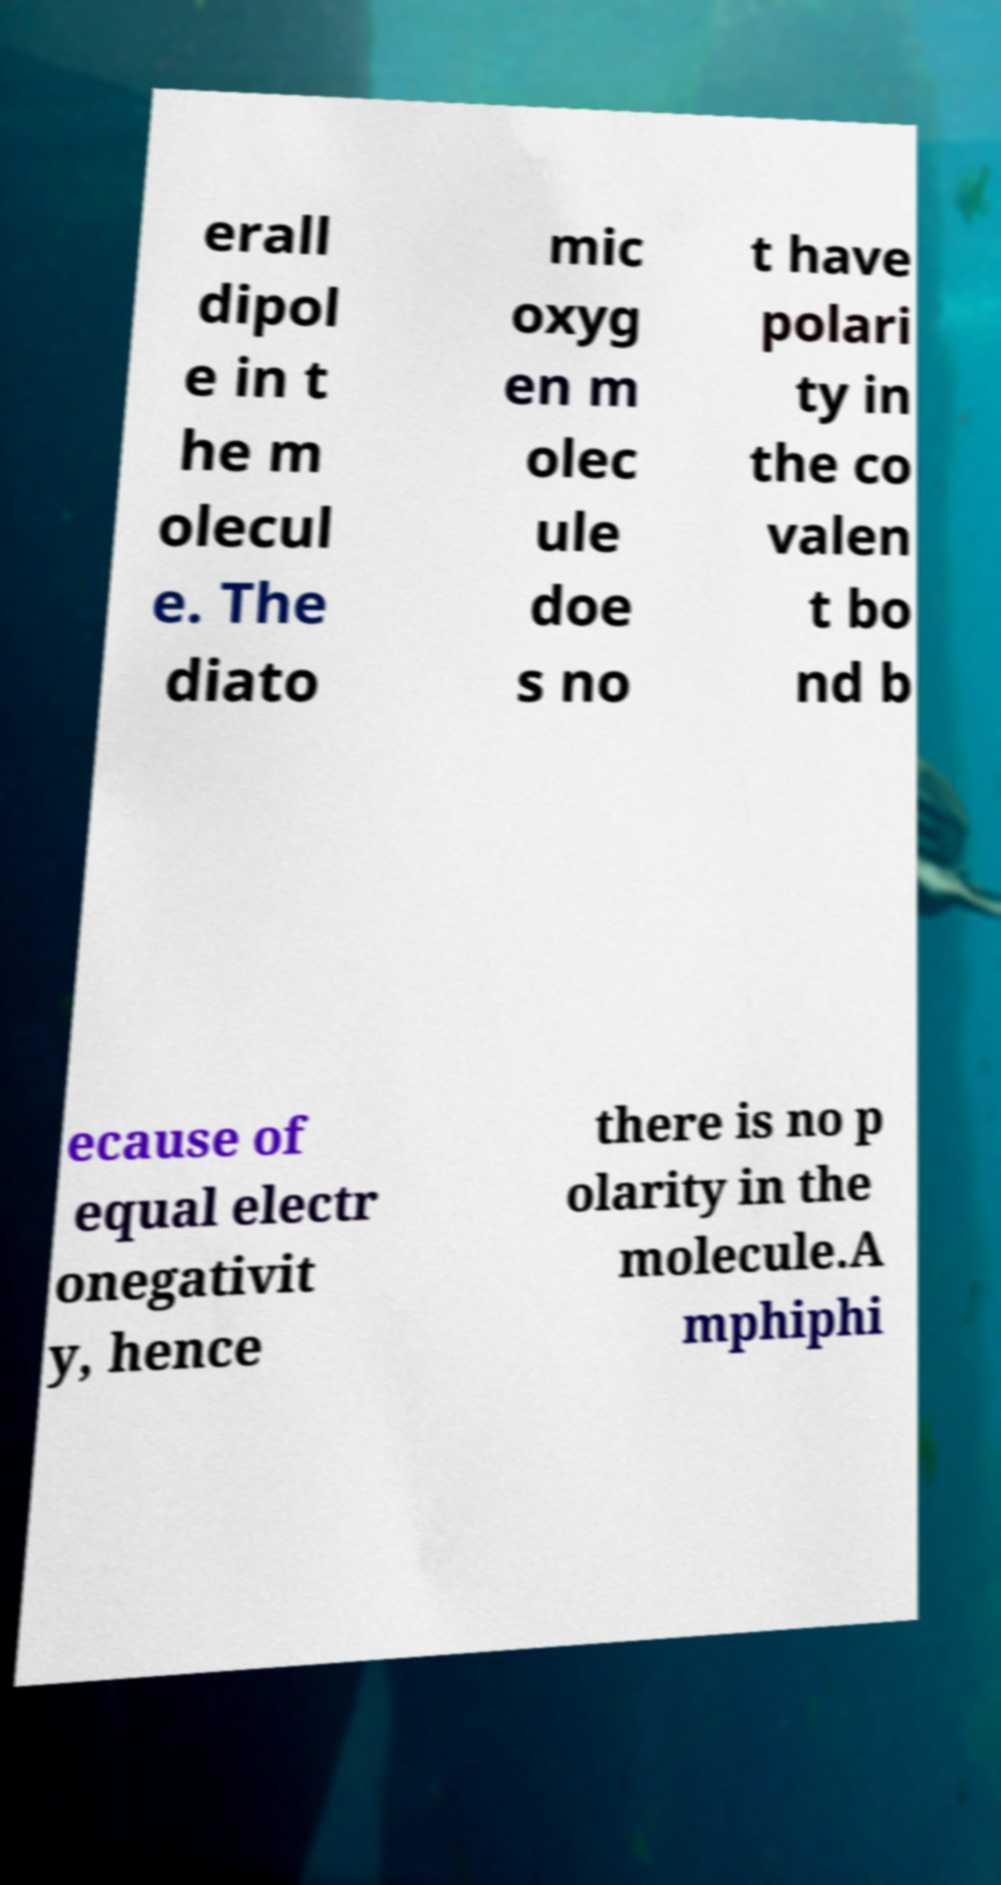I need the written content from this picture converted into text. Can you do that? erall dipol e in t he m olecul e. The diato mic oxyg en m olec ule doe s no t have polari ty in the co valen t bo nd b ecause of equal electr onegativit y, hence there is no p olarity in the molecule.A mphiphi 